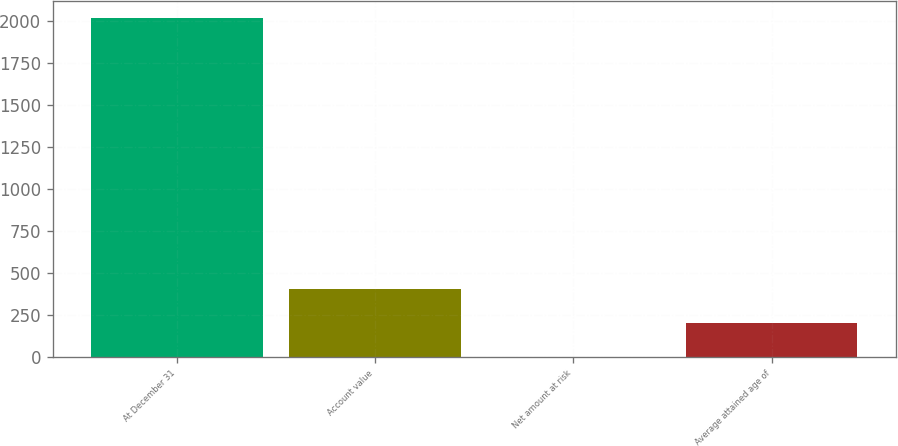Convert chart. <chart><loc_0><loc_0><loc_500><loc_500><bar_chart><fcel>At December 31<fcel>Account value<fcel>Net amount at risk<fcel>Average attained age of<nl><fcel>2015<fcel>404.6<fcel>2<fcel>203.3<nl></chart> 